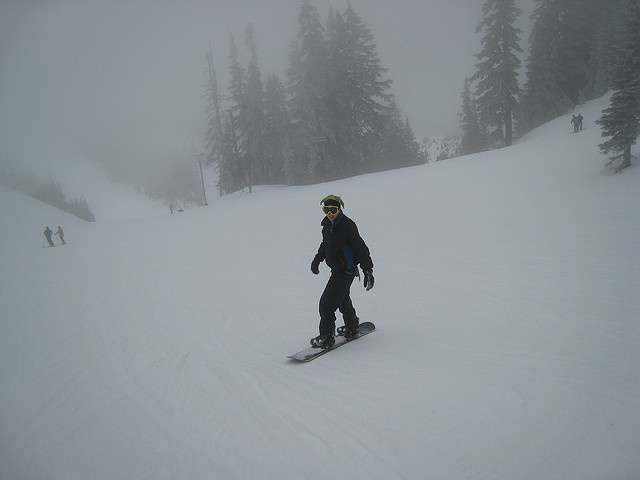Describe the objects in this image and their specific colors. I can see people in gray, black, darkgray, and lightgray tones, snowboard in gray, darkgray, black, and purple tones, people in gray tones, people in gray tones, and people in gray tones in this image. 